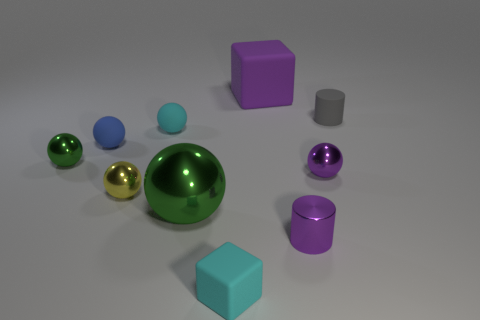There is a cyan object behind the rubber object that is in front of the shiny sphere that is right of the big green thing; what is its size?
Provide a succinct answer. Small. What number of yellow cylinders have the same size as the purple shiny cylinder?
Provide a short and direct response. 0. How many things are small metal cylinders or cylinders behind the tiny blue sphere?
Give a very brief answer. 2. The small gray matte object is what shape?
Your answer should be compact. Cylinder. Do the tiny metallic cylinder and the large matte cube have the same color?
Offer a terse response. Yes. What is the color of the cube that is the same size as the gray rubber thing?
Provide a succinct answer. Cyan. How many blue things are small matte blocks or large matte cylinders?
Provide a succinct answer. 0. Are there more large purple cubes than tiny shiny spheres?
Give a very brief answer. No. There is a block that is in front of the small purple metallic sphere; is its size the same as the rubber block behind the small cyan matte cube?
Offer a very short reply. No. What is the color of the tiny cylinder in front of the green metal ball on the left side of the small yellow sphere to the left of the small gray rubber cylinder?
Offer a very short reply. Purple. 